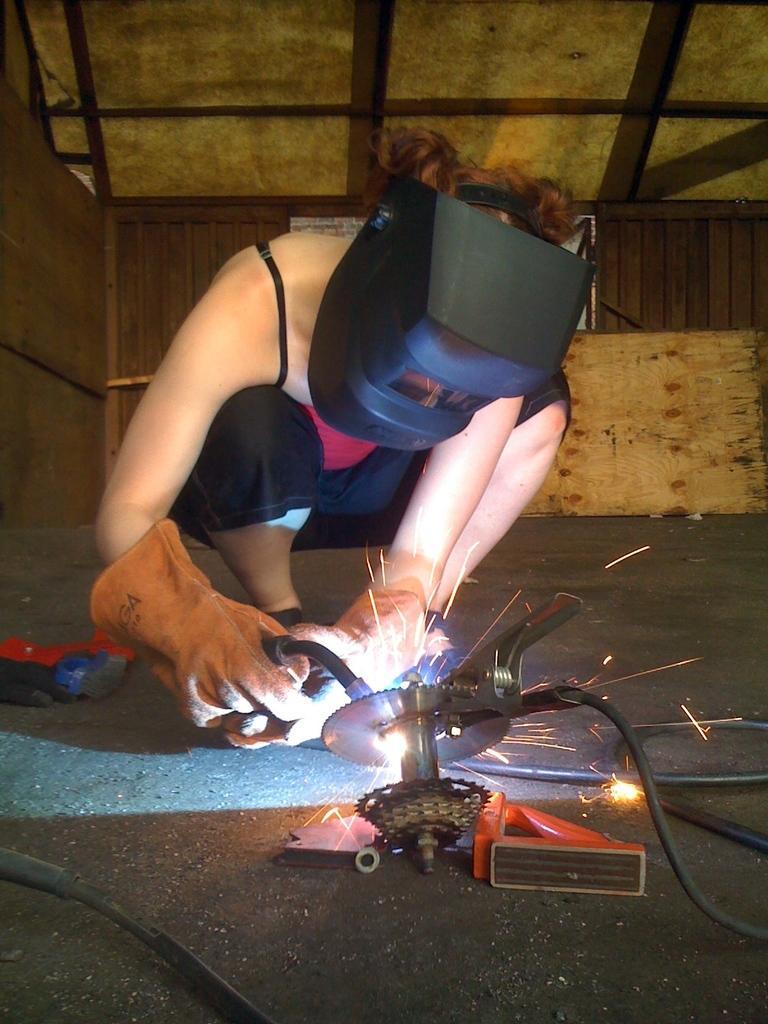Could you give a brief overview of what you see in this image? In the center of the image we can see a person wearing the mask and a glove holding a tool. We can also see a device, some pipes, for work and some objects which are placed on the ground. On the backside we can see a wooden wall. 